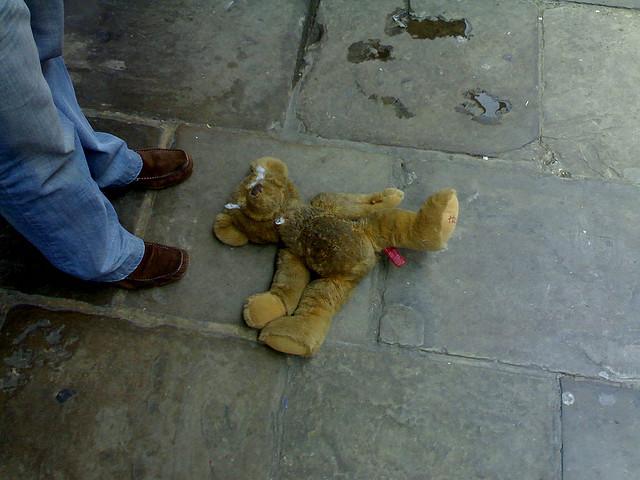Did someone place the stuffed animal there?
Answer briefly. Yes. Has the bear been damaged?
Short answer required. Yes. What is the sidewalk made of?
Give a very brief answer. Concrete. Does this bear have a head?
Keep it brief. Yes. Is the child about the same size as the bear?
Write a very short answer. No. What is lying on the floor?
Short answer required. Teddy bear. Is this a brand new teddy bear?
Concise answer only. No. What species of bear is shown?
Short answer required. Stuffed. 